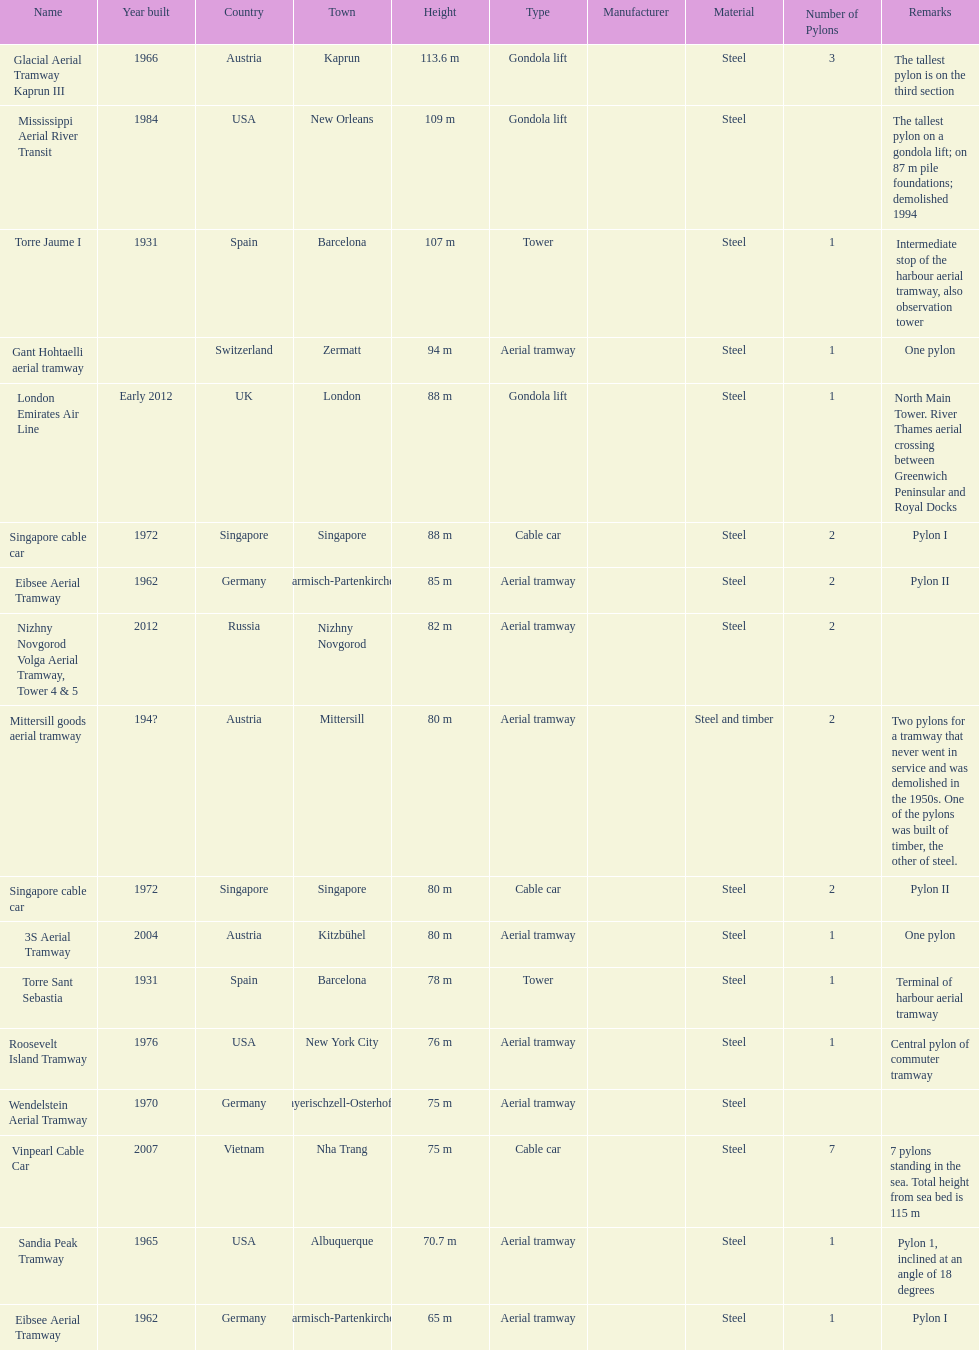What is the total number of tallest pylons in austria? 3. 